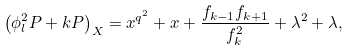Convert formula to latex. <formula><loc_0><loc_0><loc_500><loc_500>\left ( \phi _ { l } ^ { 2 } P + k P \right ) _ { X } = x ^ { q ^ { 2 } } + x + \frac { f _ { k - 1 } f _ { k + 1 } } { f _ { k } ^ { 2 } } + \lambda ^ { 2 } + \lambda ,</formula> 